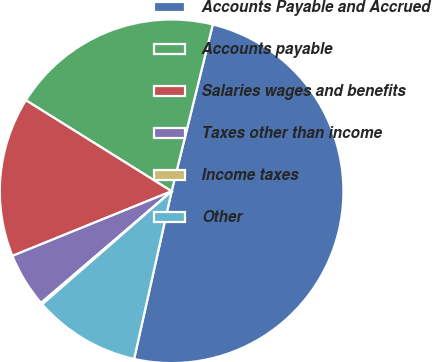Convert chart. <chart><loc_0><loc_0><loc_500><loc_500><pie_chart><fcel>Accounts Payable and Accrued<fcel>Accounts payable<fcel>Salaries wages and benefits<fcel>Taxes other than income<fcel>Income taxes<fcel>Other<nl><fcel>49.65%<fcel>19.97%<fcel>15.02%<fcel>5.12%<fcel>0.17%<fcel>10.07%<nl></chart> 